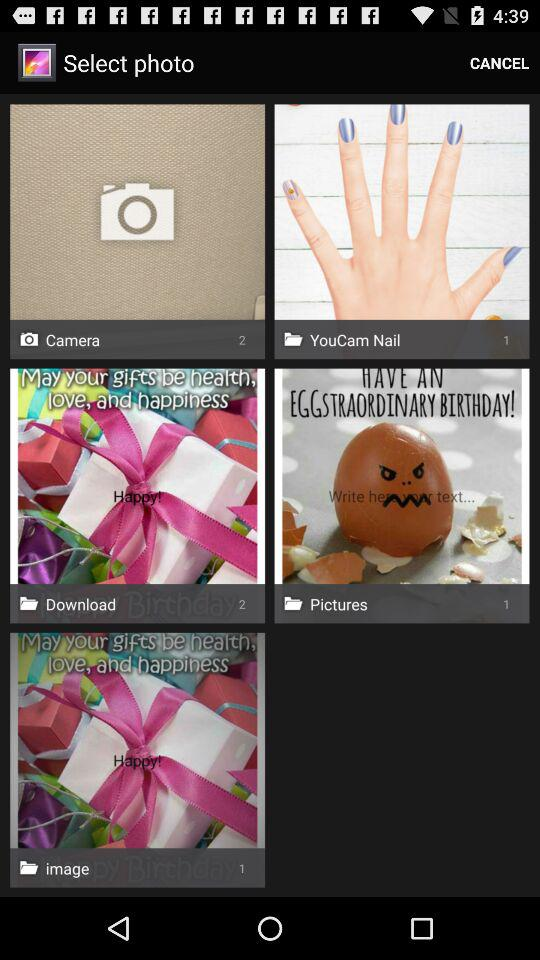What is the count of downloaded images? The count of downloaded images is 2. 